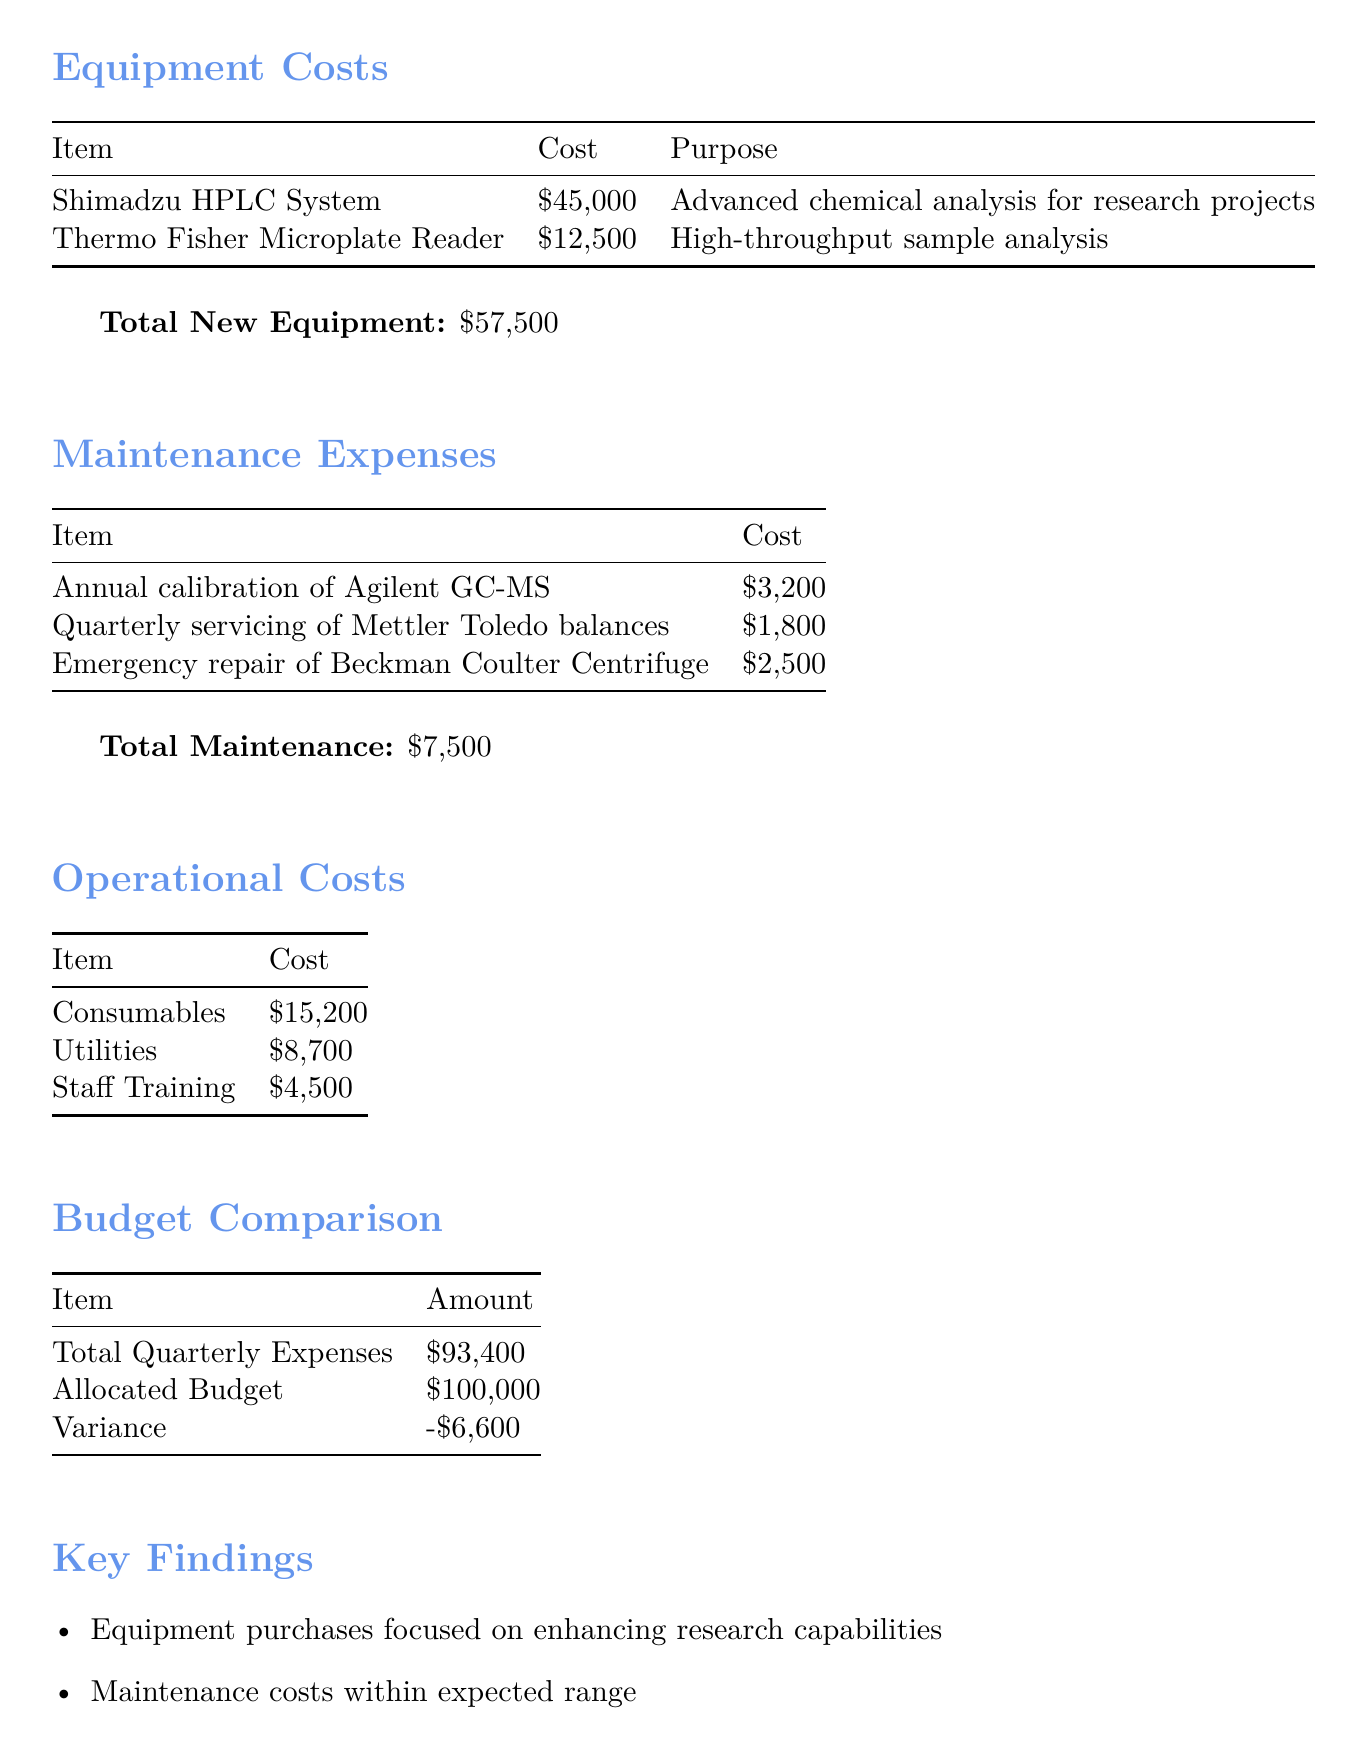What is the title of the report? The title of the report is specified at the beginning of the document.
Answer: Quarterly Financial Analysis: University Quality Control Lab What was the total cost of new equipment? The document states the total new equipment cost under the equipment costs section.
Answer: $57,500 What was the cost of the Shimadzu HPLC System? The document provides individual costs for new purchases, including the Shimadzu HPLC System.
Answer: $45,000 What are the total maintenance expenses? The total maintenance expenses are listed under the maintenance expenses section of the document.
Answer: $7,500 What was the allocated budget for Q3 2023? The allocated budget is explicitly mentioned in the budget comparison section.
Answer: $100,000 How much did the lab spend on operational costs for consumables? The operational costs section lists the expenditures, including consumables.
Answer: $15,200 What is the variance between total quarterly expenses and the allocated budget? The variance is indicated under the budget comparison section, calculated as the difference between total expenses and the budget.
Answer: -$6,600 What equipment purchase aimed to enhance research capabilities? The key findings mention a focus of the equipment purchases in improving the lab's research capabilities.
Answer: Shimadzu HPLC System What recommendation is given regarding staff development? The recommendations section suggests allocating surplus funds.
Answer: Allocate surplus to staff development programs 